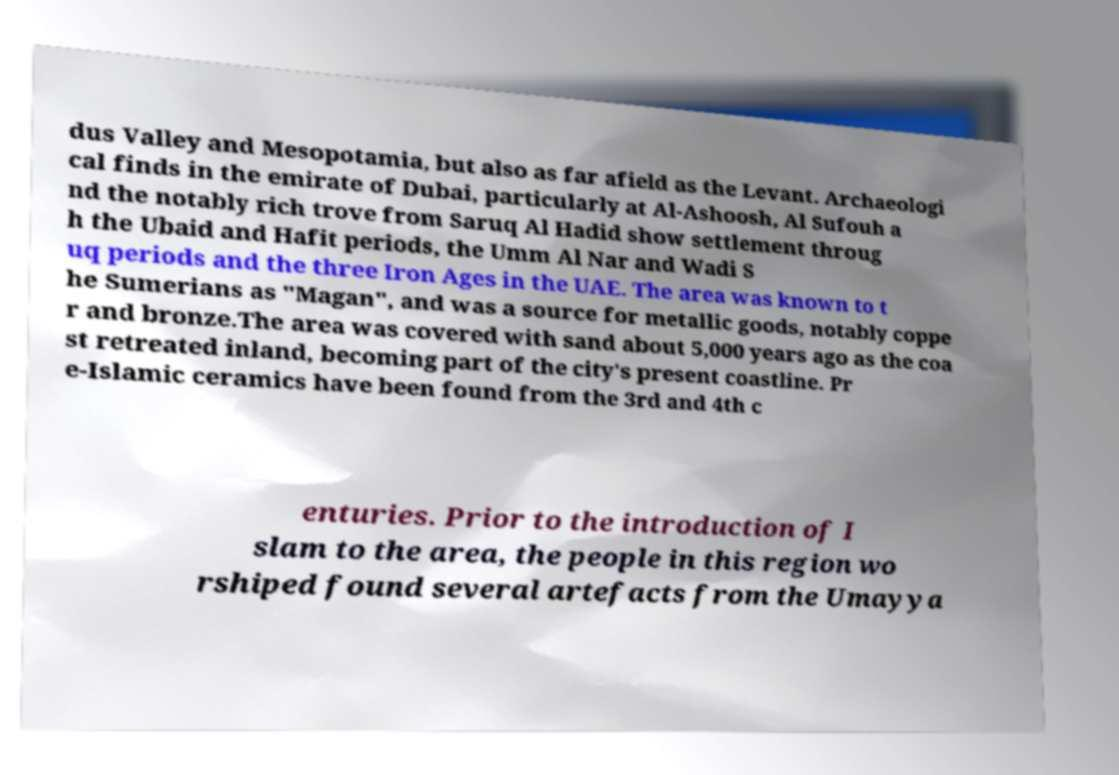What messages or text are displayed in this image? I need them in a readable, typed format. dus Valley and Mesopotamia, but also as far afield as the Levant. Archaeologi cal finds in the emirate of Dubai, particularly at Al-Ashoosh, Al Sufouh a nd the notably rich trove from Saruq Al Hadid show settlement throug h the Ubaid and Hafit periods, the Umm Al Nar and Wadi S uq periods and the three Iron Ages in the UAE. The area was known to t he Sumerians as "Magan", and was a source for metallic goods, notably coppe r and bronze.The area was covered with sand about 5,000 years ago as the coa st retreated inland, becoming part of the city's present coastline. Pr e-Islamic ceramics have been found from the 3rd and 4th c enturies. Prior to the introduction of I slam to the area, the people in this region wo rshiped found several artefacts from the Umayya 